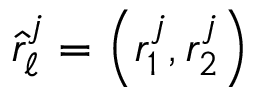<formula> <loc_0><loc_0><loc_500><loc_500>\hat { r } _ { \ell } ^ { j } = \left ( r _ { 1 } ^ { j } , r _ { 2 } ^ { j } \right )</formula> 